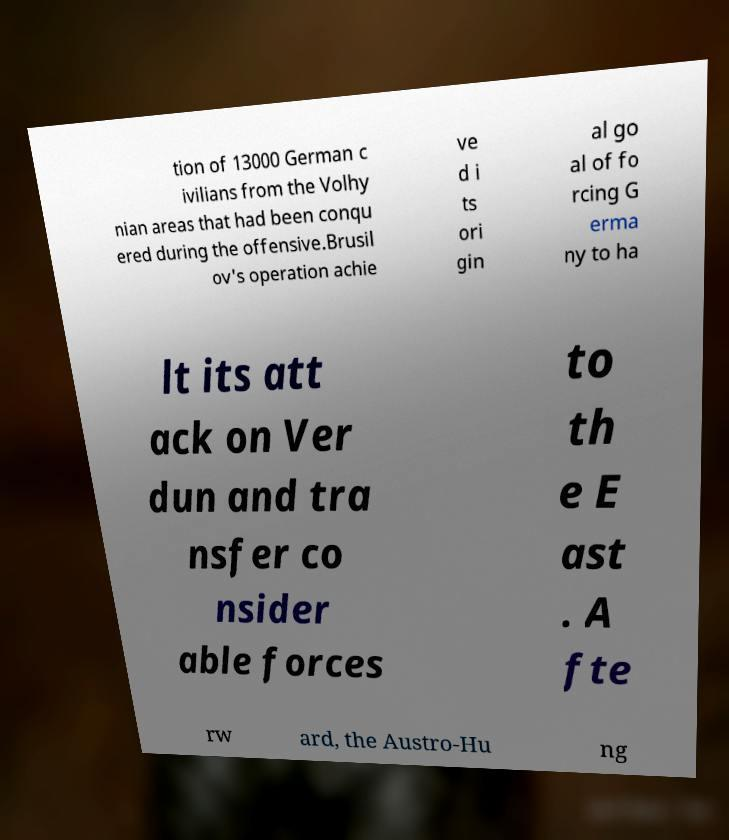I need the written content from this picture converted into text. Can you do that? tion of 13000 German c ivilians from the Volhy nian areas that had been conqu ered during the offensive.Brusil ov's operation achie ve d i ts ori gin al go al of fo rcing G erma ny to ha lt its att ack on Ver dun and tra nsfer co nsider able forces to th e E ast . A fte rw ard, the Austro-Hu ng 